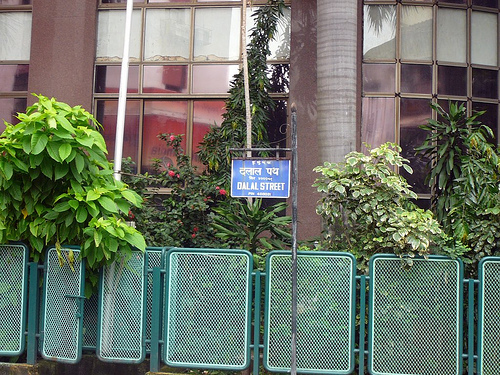Identify and read out the text in this image. STREET DALAL 